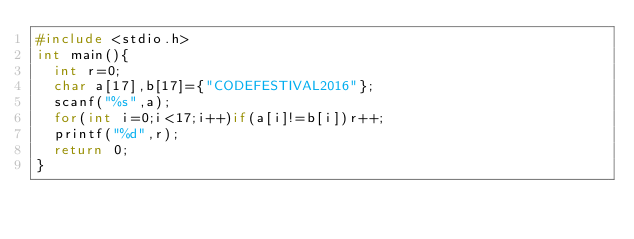Convert code to text. <code><loc_0><loc_0><loc_500><loc_500><_C_>#include <stdio.h>
int main(){
  int r=0;
  char a[17],b[17]={"CODEFESTIVAL2016"};
  scanf("%s",a);
  for(int i=0;i<17;i++)if(a[i]!=b[i])r++;
  printf("%d",r);
  return 0;
}</code> 